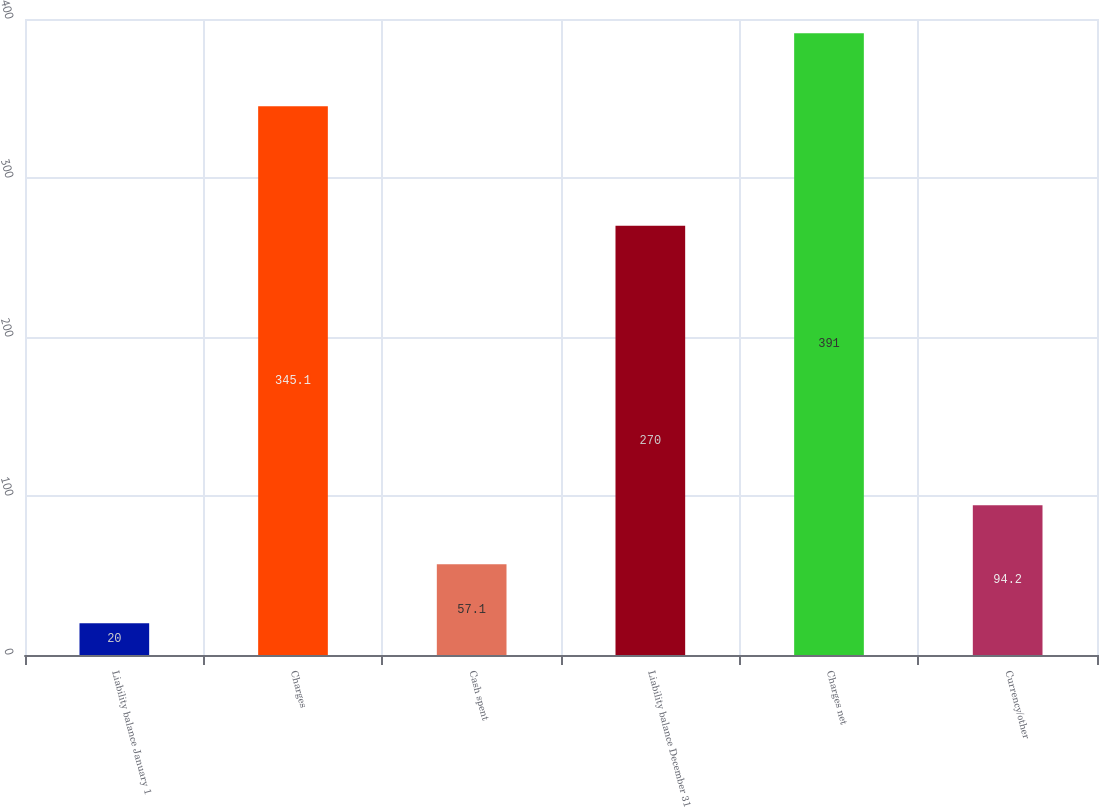Convert chart to OTSL. <chart><loc_0><loc_0><loc_500><loc_500><bar_chart><fcel>Liability balance January 1<fcel>Charges<fcel>Cash spent<fcel>Liability balance December 31<fcel>Charges net<fcel>Currency/other<nl><fcel>20<fcel>345.1<fcel>57.1<fcel>270<fcel>391<fcel>94.2<nl></chart> 